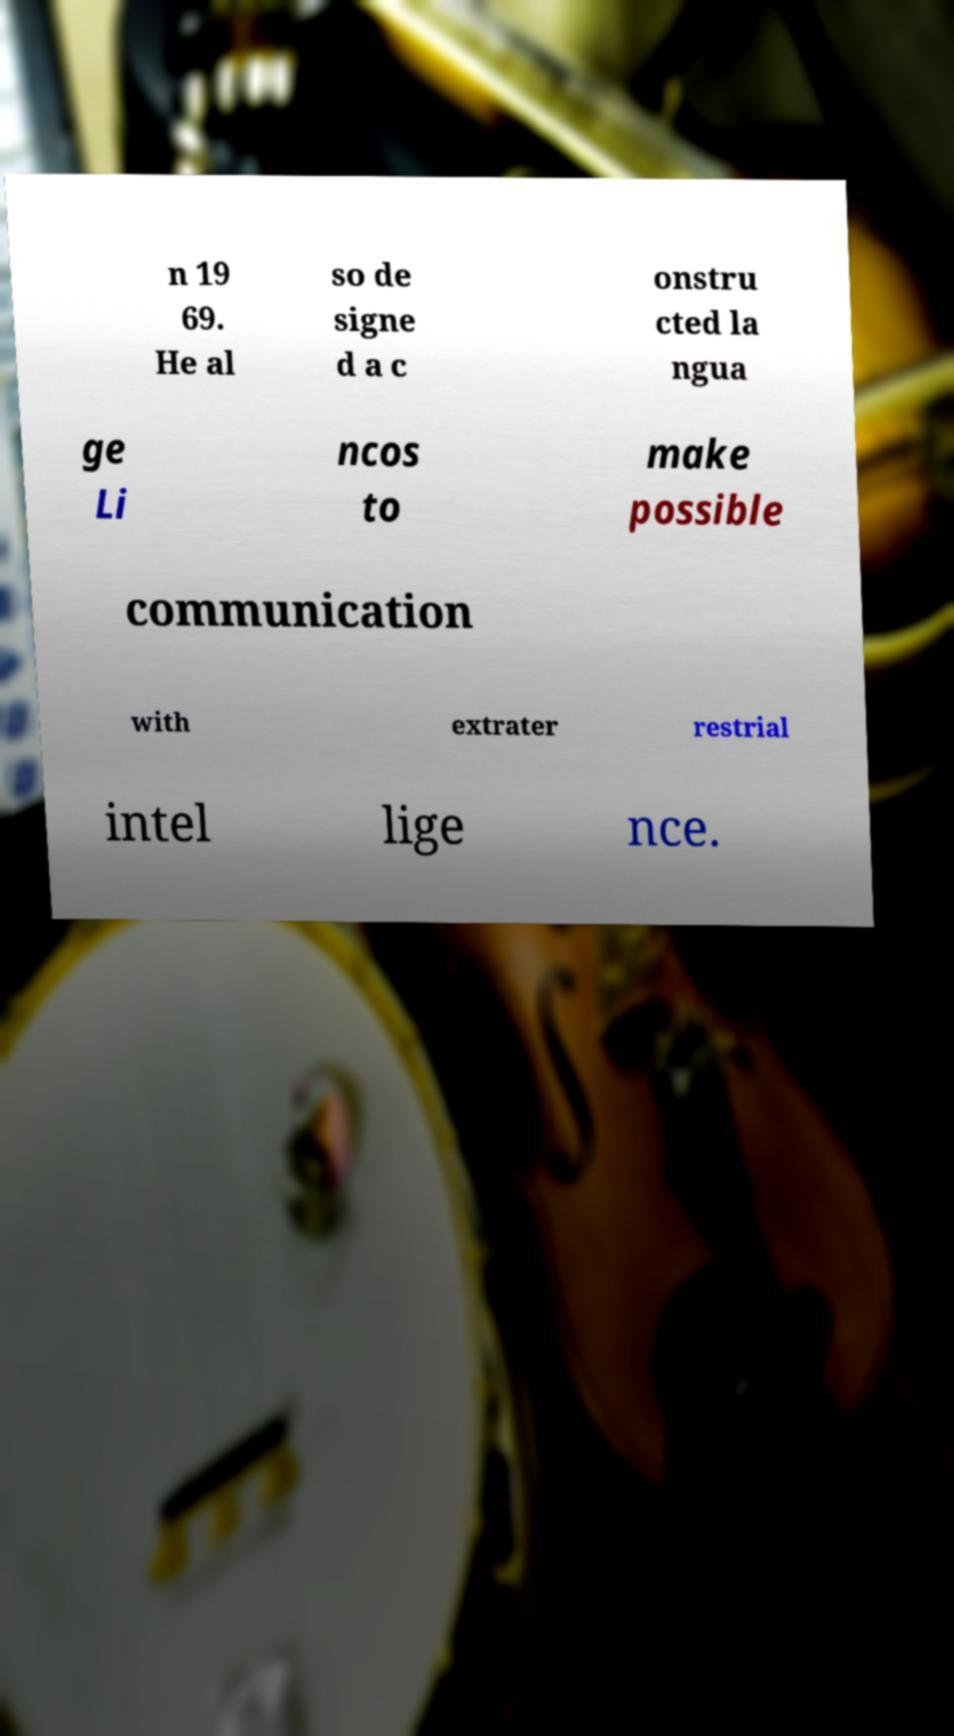Could you extract and type out the text from this image? n 19 69. He al so de signe d a c onstru cted la ngua ge Li ncos to make possible communication with extrater restrial intel lige nce. 